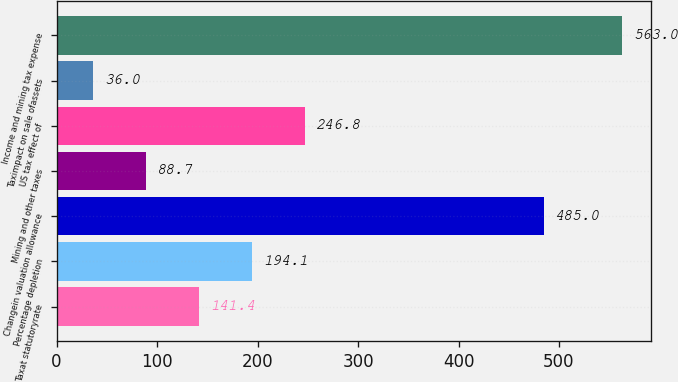<chart> <loc_0><loc_0><loc_500><loc_500><bar_chart><fcel>Taxat statutoryrate<fcel>Percentage depletion<fcel>Changein valuation allowance<fcel>Mining and other taxes<fcel>US tax effect of<fcel>Taximpact on sale ofassets<fcel>Income and mining tax expense<nl><fcel>141.4<fcel>194.1<fcel>485<fcel>88.7<fcel>246.8<fcel>36<fcel>563<nl></chart> 